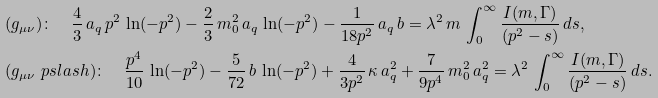Convert formula to latex. <formula><loc_0><loc_0><loc_500><loc_500>& ( g _ { \mu \nu } ) \colon \quad \frac { 4 } { 3 } \, a _ { q } \, p ^ { 2 } \, \ln ( - p ^ { 2 } ) - \frac { 2 } { 3 } \, m _ { 0 } ^ { 2 } \, a _ { q } \, \ln ( - p ^ { 2 } ) - \frac { 1 } { 1 8 p ^ { 2 } } \, a _ { q } \, b = \lambda ^ { 2 } \, m \, \int ^ { \infty } _ { 0 } \frac { I ( m , \Gamma ) } { ( p ^ { 2 } - s ) } \, d s , \\ & ( g _ { \mu \nu } \ p s l a s h ) \colon \quad \frac { p ^ { 4 } } { 1 0 } \, \ln ( - p ^ { 2 } ) - \frac { 5 } { 7 2 } \, b \, \ln ( - p ^ { 2 } ) + \frac { 4 } { 3 p ^ { 2 } } \, \kappa \, a _ { q } ^ { 2 } + \frac { 7 } { 9 p ^ { 4 } } \, m _ { 0 } ^ { 2 } \, a _ { q } ^ { 2 } = \lambda ^ { 2 } \, \int ^ { \infty } _ { 0 } \frac { I ( m , \Gamma ) } { ( p ^ { 2 } - s ) } \, d s .</formula> 